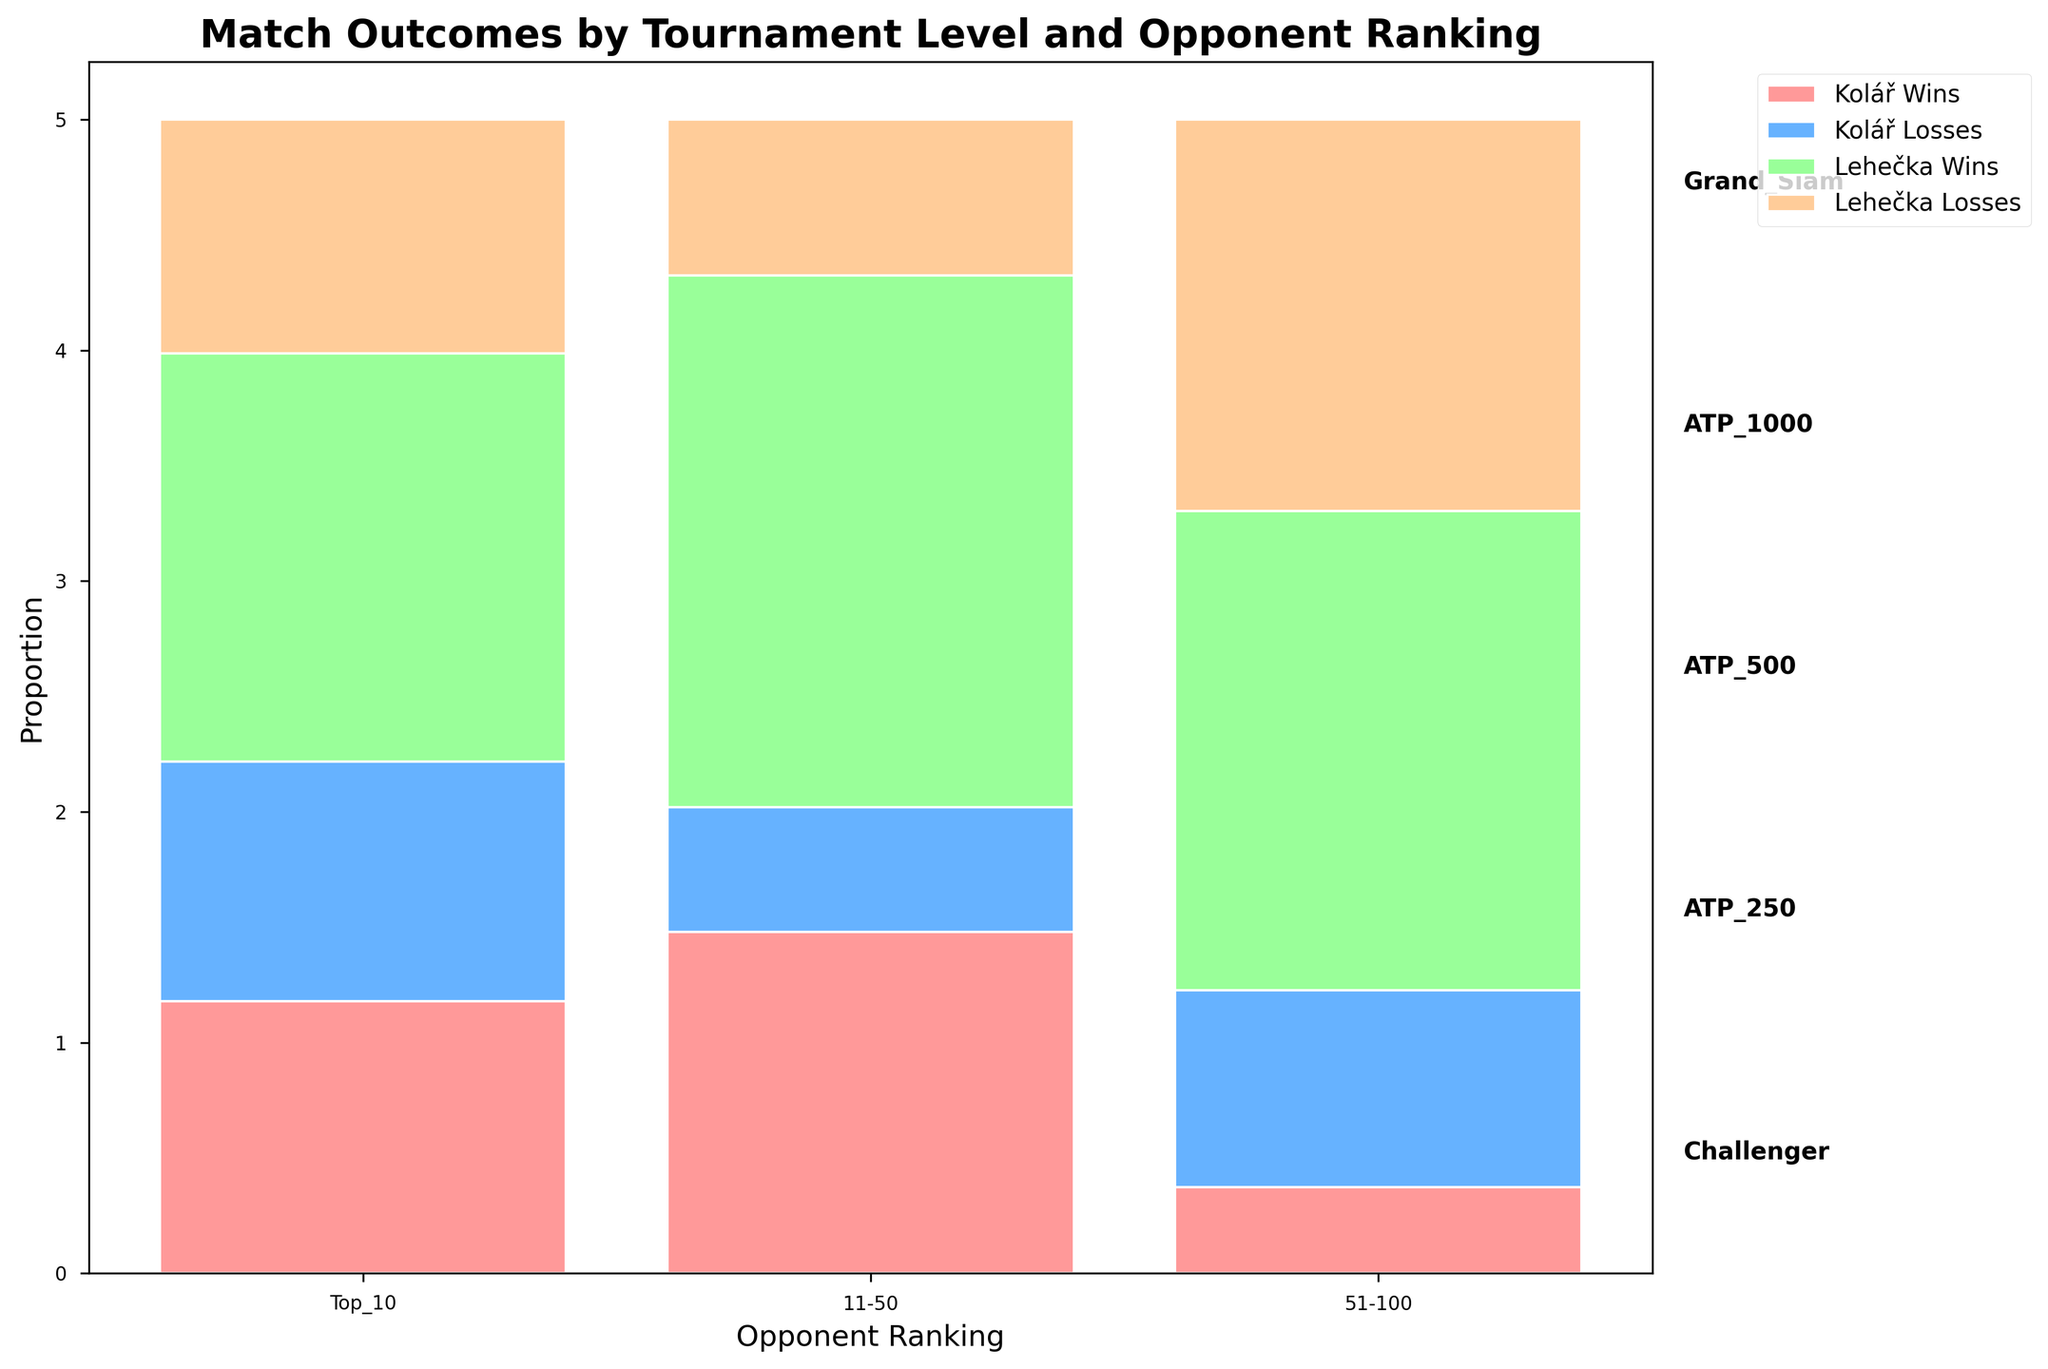How many sections represent Kolář's wins? The bar is divided into four types: Kolář Wins, Kolář Losses, Lehečka Wins, Lehečka Losses. By observation, there are multiple sections representing Kolář's wins across different opponent rankings. Specifically, there are 6 sections.
Answer: 6 What is the proportion of Lehečka's wins against opponents ranked 11-50 in Grand Slam tournaments? Look at the segment labeled "Lehečka Wins" under the Grand Slam tournament level for opponents ranked 11-50. Identify the height of this section and compare it to the total height (which sums to 1). According to the bar heights, Lehečka wins 3 matches out of a total of 13 instances (1+3+4+5) for Grand Slam and 11-50 rankings. The proportional height for Lehečka's wins is 3/13.
Answer: 3/13 Between Kolář and Lehečka, who has more losses against Top 10 opponents in ATP 250 tournaments? Look at the segments of the ATP 250 level for Top 10 opponents. Kolář's losses in this section are marked by a different color than Lehečka's losses. Kolář has 1 loss, while Lehečka has 2 losses.
Answer: Lehečka What is the total number of wins for Kolář and Lehečka at the ATP 500 level? Sum all the win sections for Kolář and Lehečka at the ATP 500 level. Kolář wins are represented in 3-4-5-7 wins across opponent rankings (Top10, 11-50, 51-100). Lehečka wins add two more wins in Top10, four more for 11-50, and six for 51-100. In total, 3+4+5 for Kolář and 2+4+6 for Lehečka making a total sum. Calculate the total: Kolář (12) + Lehečka (12).
Answer: 24 Which tournament level has the highest proportion of Kolář wins against opponents ranked 51-100? Compare the heights of Kolář's wins against opponents ranked 51-100 across all tournament levels. Observe that the heights represent this proportion, especially highlighted in the Challenger category which appears to have the highest segment. Kolář wins are 6 out of total 11 Challenger Level matches in this category.
Answer: Challenger 